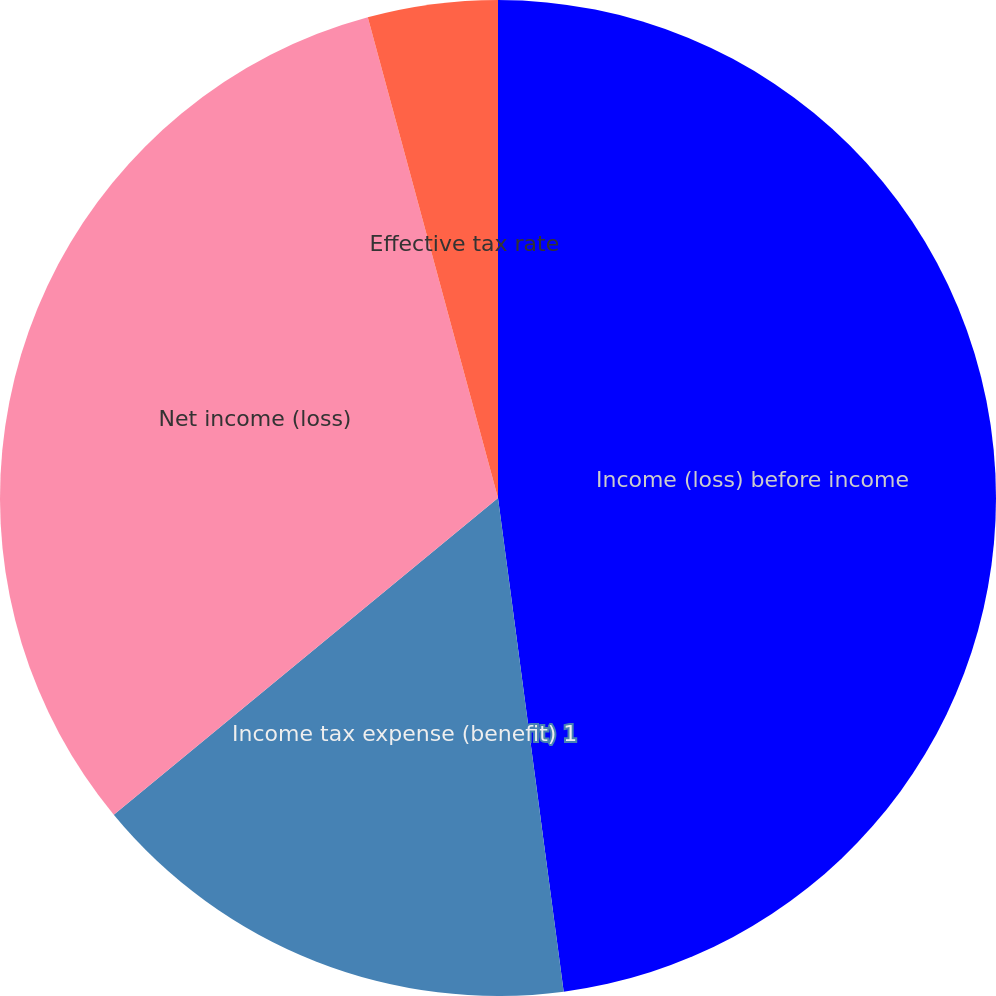Convert chart. <chart><loc_0><loc_0><loc_500><loc_500><pie_chart><fcel>Income (loss) before income<fcel>Income tax expense (benefit) 1<fcel>Net income (loss)<fcel>Effective tax rate<nl><fcel>47.89%<fcel>16.13%<fcel>31.76%<fcel>4.21%<nl></chart> 